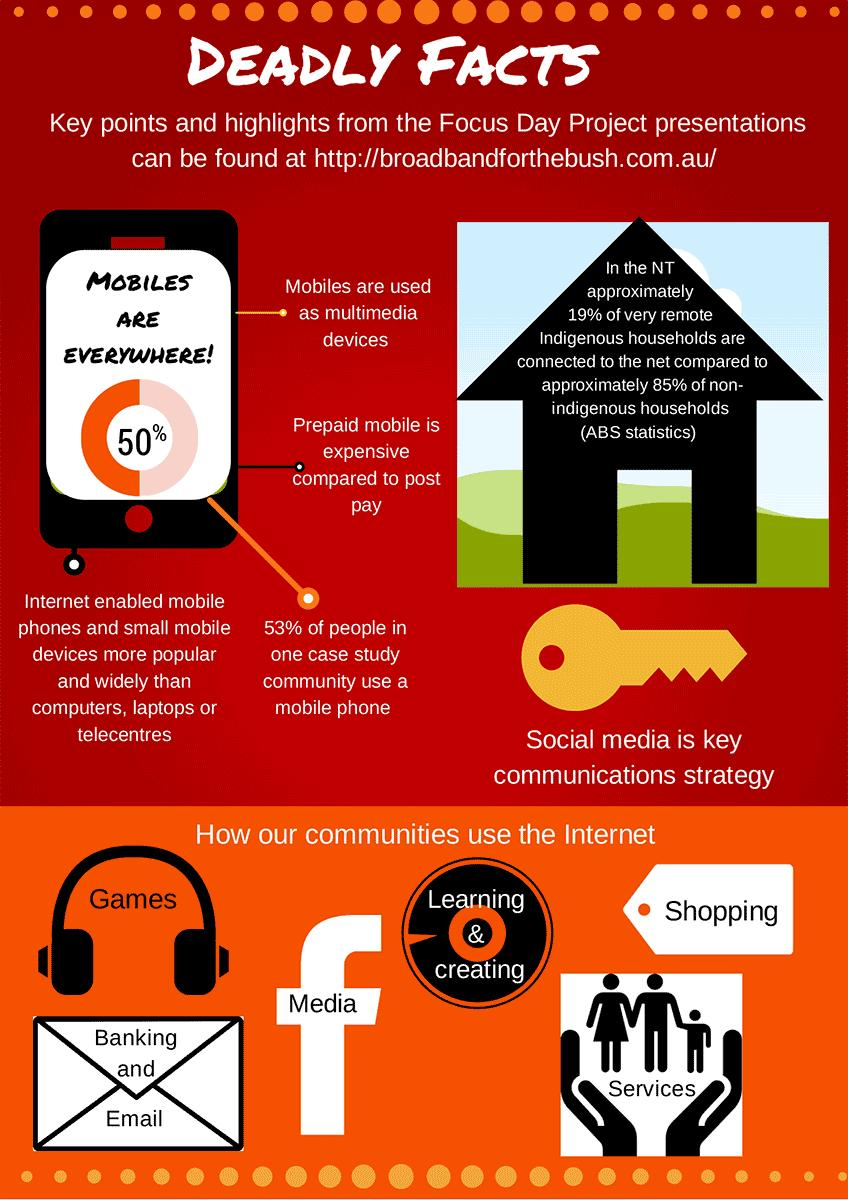Outline some significant characteristics in this image. Facebook's logo can be seen in four colors: black, white, red, and blue. The logo is usually displayed in white. The text written inside the Facebook logo is "Media. There are six different types of Internet usage depicted in the infographic. The major reason for the widespread use of mobile phones is the internet. 